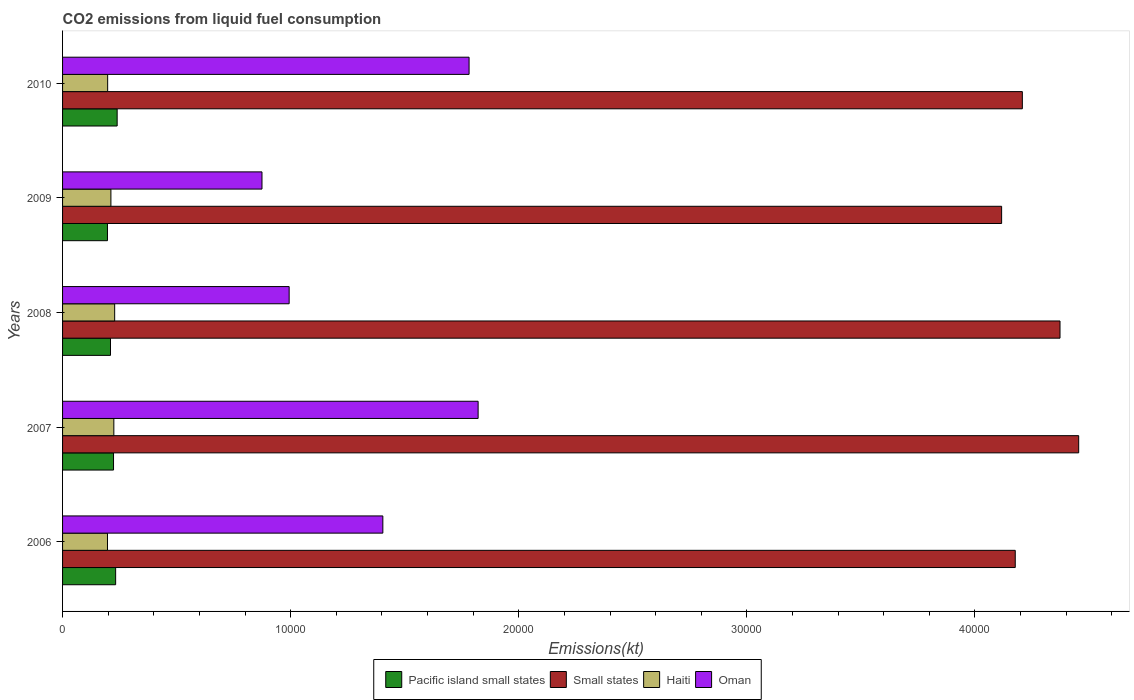How many groups of bars are there?
Your answer should be compact. 5. Are the number of bars per tick equal to the number of legend labels?
Keep it short and to the point. Yes. Are the number of bars on each tick of the Y-axis equal?
Keep it short and to the point. Yes. How many bars are there on the 5th tick from the top?
Ensure brevity in your answer.  4. What is the amount of CO2 emitted in Oman in 2006?
Ensure brevity in your answer.  1.40e+04. Across all years, what is the maximum amount of CO2 emitted in Small states?
Make the answer very short. 4.45e+04. Across all years, what is the minimum amount of CO2 emitted in Pacific island small states?
Your answer should be compact. 1968.26. In which year was the amount of CO2 emitted in Pacific island small states maximum?
Provide a succinct answer. 2010. What is the total amount of CO2 emitted in Haiti in the graph?
Keep it short and to the point. 1.06e+04. What is the difference between the amount of CO2 emitted in Haiti in 2008 and that in 2010?
Ensure brevity in your answer.  308.03. What is the difference between the amount of CO2 emitted in Pacific island small states in 2009 and the amount of CO2 emitted in Haiti in 2007?
Keep it short and to the point. -279.61. What is the average amount of CO2 emitted in Haiti per year?
Provide a short and direct response. 2119.53. In the year 2008, what is the difference between the amount of CO2 emitted in Haiti and amount of CO2 emitted in Small states?
Provide a short and direct response. -4.14e+04. In how many years, is the amount of CO2 emitted in Small states greater than 6000 kt?
Your response must be concise. 5. What is the ratio of the amount of CO2 emitted in Pacific island small states in 2008 to that in 2009?
Offer a terse response. 1.07. Is the amount of CO2 emitted in Haiti in 2006 less than that in 2008?
Provide a short and direct response. Yes. Is the difference between the amount of CO2 emitted in Haiti in 2007 and 2008 greater than the difference between the amount of CO2 emitted in Small states in 2007 and 2008?
Provide a succinct answer. No. What is the difference between the highest and the second highest amount of CO2 emitted in Pacific island small states?
Provide a succinct answer. 66.47. What is the difference between the highest and the lowest amount of CO2 emitted in Oman?
Offer a terse response. 9475.53. Is the sum of the amount of CO2 emitted in Pacific island small states in 2007 and 2010 greater than the maximum amount of CO2 emitted in Haiti across all years?
Make the answer very short. Yes. What does the 4th bar from the top in 2006 represents?
Your answer should be very brief. Pacific island small states. What does the 4th bar from the bottom in 2006 represents?
Ensure brevity in your answer.  Oman. Are all the bars in the graph horizontal?
Provide a short and direct response. Yes. How many years are there in the graph?
Your answer should be very brief. 5. What is the difference between two consecutive major ticks on the X-axis?
Provide a short and direct response. 10000. Does the graph contain any zero values?
Provide a short and direct response. No. Does the graph contain grids?
Your answer should be very brief. No. How are the legend labels stacked?
Provide a short and direct response. Horizontal. What is the title of the graph?
Provide a short and direct response. CO2 emissions from liquid fuel consumption. Does "Dominican Republic" appear as one of the legend labels in the graph?
Your response must be concise. No. What is the label or title of the X-axis?
Give a very brief answer. Emissions(kt). What is the Emissions(kt) of Pacific island small states in 2006?
Make the answer very short. 2326.46. What is the Emissions(kt) in Small states in 2006?
Give a very brief answer. 4.18e+04. What is the Emissions(kt) of Haiti in 2006?
Your answer should be compact. 1969.18. What is the Emissions(kt) of Oman in 2006?
Your answer should be compact. 1.40e+04. What is the Emissions(kt) of Pacific island small states in 2007?
Offer a very short reply. 2234.14. What is the Emissions(kt) of Small states in 2007?
Provide a short and direct response. 4.45e+04. What is the Emissions(kt) in Haiti in 2007?
Keep it short and to the point. 2247.87. What is the Emissions(kt) of Oman in 2007?
Ensure brevity in your answer.  1.82e+04. What is the Emissions(kt) of Pacific island small states in 2008?
Offer a terse response. 2101.2. What is the Emissions(kt) in Small states in 2008?
Provide a short and direct response. 4.37e+04. What is the Emissions(kt) of Haiti in 2008?
Keep it short and to the point. 2284.54. What is the Emissions(kt) of Oman in 2008?
Give a very brief answer. 9933.9. What is the Emissions(kt) in Pacific island small states in 2009?
Give a very brief answer. 1968.26. What is the Emissions(kt) of Small states in 2009?
Keep it short and to the point. 4.12e+04. What is the Emissions(kt) of Haiti in 2009?
Provide a succinct answer. 2119.53. What is the Emissions(kt) in Oman in 2009?
Offer a terse response. 8742.13. What is the Emissions(kt) in Pacific island small states in 2010?
Keep it short and to the point. 2392.93. What is the Emissions(kt) of Small states in 2010?
Provide a succinct answer. 4.21e+04. What is the Emissions(kt) of Haiti in 2010?
Provide a short and direct response. 1976.51. What is the Emissions(kt) in Oman in 2010?
Ensure brevity in your answer.  1.78e+04. Across all years, what is the maximum Emissions(kt) of Pacific island small states?
Offer a terse response. 2392.93. Across all years, what is the maximum Emissions(kt) of Small states?
Your response must be concise. 4.45e+04. Across all years, what is the maximum Emissions(kt) in Haiti?
Keep it short and to the point. 2284.54. Across all years, what is the maximum Emissions(kt) in Oman?
Make the answer very short. 1.82e+04. Across all years, what is the minimum Emissions(kt) of Pacific island small states?
Ensure brevity in your answer.  1968.26. Across all years, what is the minimum Emissions(kt) of Small states?
Give a very brief answer. 4.12e+04. Across all years, what is the minimum Emissions(kt) of Haiti?
Ensure brevity in your answer.  1969.18. Across all years, what is the minimum Emissions(kt) in Oman?
Your answer should be very brief. 8742.13. What is the total Emissions(kt) in Pacific island small states in the graph?
Your answer should be very brief. 1.10e+04. What is the total Emissions(kt) in Small states in the graph?
Your answer should be very brief. 2.13e+05. What is the total Emissions(kt) in Haiti in the graph?
Your response must be concise. 1.06e+04. What is the total Emissions(kt) in Oman in the graph?
Offer a very short reply. 6.88e+04. What is the difference between the Emissions(kt) in Pacific island small states in 2006 and that in 2007?
Give a very brief answer. 92.32. What is the difference between the Emissions(kt) of Small states in 2006 and that in 2007?
Your response must be concise. -2780.88. What is the difference between the Emissions(kt) of Haiti in 2006 and that in 2007?
Your response must be concise. -278.69. What is the difference between the Emissions(kt) in Oman in 2006 and that in 2007?
Provide a succinct answer. -4176.71. What is the difference between the Emissions(kt) in Pacific island small states in 2006 and that in 2008?
Offer a very short reply. 225.26. What is the difference between the Emissions(kt) in Small states in 2006 and that in 2008?
Offer a terse response. -1962.45. What is the difference between the Emissions(kt) of Haiti in 2006 and that in 2008?
Your answer should be very brief. -315.36. What is the difference between the Emissions(kt) in Oman in 2006 and that in 2008?
Give a very brief answer. 4107.04. What is the difference between the Emissions(kt) in Pacific island small states in 2006 and that in 2009?
Your answer should be very brief. 358.2. What is the difference between the Emissions(kt) of Small states in 2006 and that in 2009?
Offer a very short reply. 597.47. What is the difference between the Emissions(kt) of Haiti in 2006 and that in 2009?
Your answer should be compact. -150.35. What is the difference between the Emissions(kt) in Oman in 2006 and that in 2009?
Offer a very short reply. 5298.81. What is the difference between the Emissions(kt) of Pacific island small states in 2006 and that in 2010?
Your answer should be very brief. -66.47. What is the difference between the Emissions(kt) of Small states in 2006 and that in 2010?
Your answer should be compact. -310.65. What is the difference between the Emissions(kt) in Haiti in 2006 and that in 2010?
Give a very brief answer. -7.33. What is the difference between the Emissions(kt) of Oman in 2006 and that in 2010?
Provide a succinct answer. -3780.68. What is the difference between the Emissions(kt) in Pacific island small states in 2007 and that in 2008?
Your response must be concise. 132.94. What is the difference between the Emissions(kt) in Small states in 2007 and that in 2008?
Offer a terse response. 818.43. What is the difference between the Emissions(kt) of Haiti in 2007 and that in 2008?
Your answer should be very brief. -36.67. What is the difference between the Emissions(kt) of Oman in 2007 and that in 2008?
Your answer should be compact. 8283.75. What is the difference between the Emissions(kt) in Pacific island small states in 2007 and that in 2009?
Make the answer very short. 265.88. What is the difference between the Emissions(kt) of Small states in 2007 and that in 2009?
Ensure brevity in your answer.  3378.35. What is the difference between the Emissions(kt) in Haiti in 2007 and that in 2009?
Offer a terse response. 128.34. What is the difference between the Emissions(kt) of Oman in 2007 and that in 2009?
Keep it short and to the point. 9475.53. What is the difference between the Emissions(kt) of Pacific island small states in 2007 and that in 2010?
Your answer should be compact. -158.79. What is the difference between the Emissions(kt) in Small states in 2007 and that in 2010?
Make the answer very short. 2470.23. What is the difference between the Emissions(kt) of Haiti in 2007 and that in 2010?
Keep it short and to the point. 271.36. What is the difference between the Emissions(kt) of Oman in 2007 and that in 2010?
Give a very brief answer. 396.04. What is the difference between the Emissions(kt) in Pacific island small states in 2008 and that in 2009?
Give a very brief answer. 132.94. What is the difference between the Emissions(kt) in Small states in 2008 and that in 2009?
Your answer should be compact. 2559.92. What is the difference between the Emissions(kt) of Haiti in 2008 and that in 2009?
Your answer should be very brief. 165.01. What is the difference between the Emissions(kt) in Oman in 2008 and that in 2009?
Offer a terse response. 1191.78. What is the difference between the Emissions(kt) of Pacific island small states in 2008 and that in 2010?
Offer a very short reply. -291.73. What is the difference between the Emissions(kt) of Small states in 2008 and that in 2010?
Your answer should be very brief. 1651.8. What is the difference between the Emissions(kt) of Haiti in 2008 and that in 2010?
Your answer should be very brief. 308.03. What is the difference between the Emissions(kt) in Oman in 2008 and that in 2010?
Provide a succinct answer. -7887.72. What is the difference between the Emissions(kt) of Pacific island small states in 2009 and that in 2010?
Offer a very short reply. -424.67. What is the difference between the Emissions(kt) in Small states in 2009 and that in 2010?
Make the answer very short. -908.12. What is the difference between the Emissions(kt) in Haiti in 2009 and that in 2010?
Your answer should be compact. 143.01. What is the difference between the Emissions(kt) in Oman in 2009 and that in 2010?
Keep it short and to the point. -9079.49. What is the difference between the Emissions(kt) in Pacific island small states in 2006 and the Emissions(kt) in Small states in 2007?
Your response must be concise. -4.22e+04. What is the difference between the Emissions(kt) in Pacific island small states in 2006 and the Emissions(kt) in Haiti in 2007?
Your answer should be compact. 78.59. What is the difference between the Emissions(kt) in Pacific island small states in 2006 and the Emissions(kt) in Oman in 2007?
Ensure brevity in your answer.  -1.59e+04. What is the difference between the Emissions(kt) of Small states in 2006 and the Emissions(kt) of Haiti in 2007?
Give a very brief answer. 3.95e+04. What is the difference between the Emissions(kt) in Small states in 2006 and the Emissions(kt) in Oman in 2007?
Offer a very short reply. 2.35e+04. What is the difference between the Emissions(kt) of Haiti in 2006 and the Emissions(kt) of Oman in 2007?
Offer a very short reply. -1.62e+04. What is the difference between the Emissions(kt) of Pacific island small states in 2006 and the Emissions(kt) of Small states in 2008?
Give a very brief answer. -4.14e+04. What is the difference between the Emissions(kt) in Pacific island small states in 2006 and the Emissions(kt) in Haiti in 2008?
Your response must be concise. 41.92. What is the difference between the Emissions(kt) of Pacific island small states in 2006 and the Emissions(kt) of Oman in 2008?
Your answer should be very brief. -7607.44. What is the difference between the Emissions(kt) of Small states in 2006 and the Emissions(kt) of Haiti in 2008?
Your answer should be very brief. 3.95e+04. What is the difference between the Emissions(kt) of Small states in 2006 and the Emissions(kt) of Oman in 2008?
Provide a succinct answer. 3.18e+04. What is the difference between the Emissions(kt) of Haiti in 2006 and the Emissions(kt) of Oman in 2008?
Your answer should be compact. -7964.72. What is the difference between the Emissions(kt) in Pacific island small states in 2006 and the Emissions(kt) in Small states in 2009?
Your answer should be compact. -3.88e+04. What is the difference between the Emissions(kt) of Pacific island small states in 2006 and the Emissions(kt) of Haiti in 2009?
Give a very brief answer. 206.94. What is the difference between the Emissions(kt) in Pacific island small states in 2006 and the Emissions(kt) in Oman in 2009?
Your answer should be compact. -6415.66. What is the difference between the Emissions(kt) of Small states in 2006 and the Emissions(kt) of Haiti in 2009?
Ensure brevity in your answer.  3.96e+04. What is the difference between the Emissions(kt) in Small states in 2006 and the Emissions(kt) in Oman in 2009?
Offer a terse response. 3.30e+04. What is the difference between the Emissions(kt) of Haiti in 2006 and the Emissions(kt) of Oman in 2009?
Your answer should be very brief. -6772.95. What is the difference between the Emissions(kt) of Pacific island small states in 2006 and the Emissions(kt) of Small states in 2010?
Keep it short and to the point. -3.97e+04. What is the difference between the Emissions(kt) in Pacific island small states in 2006 and the Emissions(kt) in Haiti in 2010?
Offer a very short reply. 349.95. What is the difference between the Emissions(kt) of Pacific island small states in 2006 and the Emissions(kt) of Oman in 2010?
Provide a short and direct response. -1.55e+04. What is the difference between the Emissions(kt) in Small states in 2006 and the Emissions(kt) in Haiti in 2010?
Offer a very short reply. 3.98e+04. What is the difference between the Emissions(kt) in Small states in 2006 and the Emissions(kt) in Oman in 2010?
Keep it short and to the point. 2.39e+04. What is the difference between the Emissions(kt) in Haiti in 2006 and the Emissions(kt) in Oman in 2010?
Your response must be concise. -1.59e+04. What is the difference between the Emissions(kt) in Pacific island small states in 2007 and the Emissions(kt) in Small states in 2008?
Your response must be concise. -4.15e+04. What is the difference between the Emissions(kt) in Pacific island small states in 2007 and the Emissions(kt) in Haiti in 2008?
Give a very brief answer. -50.4. What is the difference between the Emissions(kt) of Pacific island small states in 2007 and the Emissions(kt) of Oman in 2008?
Your answer should be very brief. -7699.76. What is the difference between the Emissions(kt) in Small states in 2007 and the Emissions(kt) in Haiti in 2008?
Offer a very short reply. 4.23e+04. What is the difference between the Emissions(kt) of Small states in 2007 and the Emissions(kt) of Oman in 2008?
Keep it short and to the point. 3.46e+04. What is the difference between the Emissions(kt) in Haiti in 2007 and the Emissions(kt) in Oman in 2008?
Keep it short and to the point. -7686.03. What is the difference between the Emissions(kt) of Pacific island small states in 2007 and the Emissions(kt) of Small states in 2009?
Make the answer very short. -3.89e+04. What is the difference between the Emissions(kt) of Pacific island small states in 2007 and the Emissions(kt) of Haiti in 2009?
Offer a very short reply. 114.62. What is the difference between the Emissions(kt) of Pacific island small states in 2007 and the Emissions(kt) of Oman in 2009?
Your answer should be very brief. -6507.98. What is the difference between the Emissions(kt) of Small states in 2007 and the Emissions(kt) of Haiti in 2009?
Give a very brief answer. 4.24e+04. What is the difference between the Emissions(kt) of Small states in 2007 and the Emissions(kt) of Oman in 2009?
Provide a succinct answer. 3.58e+04. What is the difference between the Emissions(kt) in Haiti in 2007 and the Emissions(kt) in Oman in 2009?
Keep it short and to the point. -6494.26. What is the difference between the Emissions(kt) of Pacific island small states in 2007 and the Emissions(kt) of Small states in 2010?
Your response must be concise. -3.98e+04. What is the difference between the Emissions(kt) in Pacific island small states in 2007 and the Emissions(kt) in Haiti in 2010?
Keep it short and to the point. 257.63. What is the difference between the Emissions(kt) in Pacific island small states in 2007 and the Emissions(kt) in Oman in 2010?
Provide a succinct answer. -1.56e+04. What is the difference between the Emissions(kt) of Small states in 2007 and the Emissions(kt) of Haiti in 2010?
Provide a short and direct response. 4.26e+04. What is the difference between the Emissions(kt) in Small states in 2007 and the Emissions(kt) in Oman in 2010?
Provide a succinct answer. 2.67e+04. What is the difference between the Emissions(kt) of Haiti in 2007 and the Emissions(kt) of Oman in 2010?
Make the answer very short. -1.56e+04. What is the difference between the Emissions(kt) in Pacific island small states in 2008 and the Emissions(kt) in Small states in 2009?
Your answer should be compact. -3.91e+04. What is the difference between the Emissions(kt) in Pacific island small states in 2008 and the Emissions(kt) in Haiti in 2009?
Keep it short and to the point. -18.32. What is the difference between the Emissions(kt) in Pacific island small states in 2008 and the Emissions(kt) in Oman in 2009?
Provide a short and direct response. -6640.92. What is the difference between the Emissions(kt) in Small states in 2008 and the Emissions(kt) in Haiti in 2009?
Provide a succinct answer. 4.16e+04. What is the difference between the Emissions(kt) of Small states in 2008 and the Emissions(kt) of Oman in 2009?
Make the answer very short. 3.50e+04. What is the difference between the Emissions(kt) of Haiti in 2008 and the Emissions(kt) of Oman in 2009?
Your answer should be compact. -6457.59. What is the difference between the Emissions(kt) of Pacific island small states in 2008 and the Emissions(kt) of Small states in 2010?
Provide a short and direct response. -4.00e+04. What is the difference between the Emissions(kt) in Pacific island small states in 2008 and the Emissions(kt) in Haiti in 2010?
Offer a terse response. 124.69. What is the difference between the Emissions(kt) in Pacific island small states in 2008 and the Emissions(kt) in Oman in 2010?
Offer a terse response. -1.57e+04. What is the difference between the Emissions(kt) of Small states in 2008 and the Emissions(kt) of Haiti in 2010?
Provide a short and direct response. 4.18e+04. What is the difference between the Emissions(kt) in Small states in 2008 and the Emissions(kt) in Oman in 2010?
Provide a short and direct response. 2.59e+04. What is the difference between the Emissions(kt) in Haiti in 2008 and the Emissions(kt) in Oman in 2010?
Your response must be concise. -1.55e+04. What is the difference between the Emissions(kt) of Pacific island small states in 2009 and the Emissions(kt) of Small states in 2010?
Offer a terse response. -4.01e+04. What is the difference between the Emissions(kt) in Pacific island small states in 2009 and the Emissions(kt) in Haiti in 2010?
Give a very brief answer. -8.25. What is the difference between the Emissions(kt) in Pacific island small states in 2009 and the Emissions(kt) in Oman in 2010?
Your response must be concise. -1.59e+04. What is the difference between the Emissions(kt) of Small states in 2009 and the Emissions(kt) of Haiti in 2010?
Your response must be concise. 3.92e+04. What is the difference between the Emissions(kt) of Small states in 2009 and the Emissions(kt) of Oman in 2010?
Your response must be concise. 2.33e+04. What is the difference between the Emissions(kt) in Haiti in 2009 and the Emissions(kt) in Oman in 2010?
Provide a succinct answer. -1.57e+04. What is the average Emissions(kt) of Pacific island small states per year?
Your response must be concise. 2204.6. What is the average Emissions(kt) of Small states per year?
Your response must be concise. 4.27e+04. What is the average Emissions(kt) in Haiti per year?
Keep it short and to the point. 2119.53. What is the average Emissions(kt) of Oman per year?
Offer a terse response. 1.38e+04. In the year 2006, what is the difference between the Emissions(kt) in Pacific island small states and Emissions(kt) in Small states?
Give a very brief answer. -3.94e+04. In the year 2006, what is the difference between the Emissions(kt) in Pacific island small states and Emissions(kt) in Haiti?
Offer a very short reply. 357.29. In the year 2006, what is the difference between the Emissions(kt) of Pacific island small states and Emissions(kt) of Oman?
Your response must be concise. -1.17e+04. In the year 2006, what is the difference between the Emissions(kt) of Small states and Emissions(kt) of Haiti?
Your answer should be compact. 3.98e+04. In the year 2006, what is the difference between the Emissions(kt) of Small states and Emissions(kt) of Oman?
Offer a very short reply. 2.77e+04. In the year 2006, what is the difference between the Emissions(kt) of Haiti and Emissions(kt) of Oman?
Provide a short and direct response. -1.21e+04. In the year 2007, what is the difference between the Emissions(kt) in Pacific island small states and Emissions(kt) in Small states?
Offer a very short reply. -4.23e+04. In the year 2007, what is the difference between the Emissions(kt) of Pacific island small states and Emissions(kt) of Haiti?
Provide a succinct answer. -13.73. In the year 2007, what is the difference between the Emissions(kt) in Pacific island small states and Emissions(kt) in Oman?
Offer a terse response. -1.60e+04. In the year 2007, what is the difference between the Emissions(kt) of Small states and Emissions(kt) of Haiti?
Provide a short and direct response. 4.23e+04. In the year 2007, what is the difference between the Emissions(kt) of Small states and Emissions(kt) of Oman?
Give a very brief answer. 2.63e+04. In the year 2007, what is the difference between the Emissions(kt) of Haiti and Emissions(kt) of Oman?
Provide a succinct answer. -1.60e+04. In the year 2008, what is the difference between the Emissions(kt) of Pacific island small states and Emissions(kt) of Small states?
Provide a short and direct response. -4.16e+04. In the year 2008, what is the difference between the Emissions(kt) in Pacific island small states and Emissions(kt) in Haiti?
Provide a short and direct response. -183.34. In the year 2008, what is the difference between the Emissions(kt) in Pacific island small states and Emissions(kt) in Oman?
Provide a succinct answer. -7832.7. In the year 2008, what is the difference between the Emissions(kt) of Small states and Emissions(kt) of Haiti?
Give a very brief answer. 4.14e+04. In the year 2008, what is the difference between the Emissions(kt) of Small states and Emissions(kt) of Oman?
Offer a terse response. 3.38e+04. In the year 2008, what is the difference between the Emissions(kt) in Haiti and Emissions(kt) in Oman?
Offer a very short reply. -7649.36. In the year 2009, what is the difference between the Emissions(kt) in Pacific island small states and Emissions(kt) in Small states?
Your answer should be compact. -3.92e+04. In the year 2009, what is the difference between the Emissions(kt) of Pacific island small states and Emissions(kt) of Haiti?
Offer a very short reply. -151.26. In the year 2009, what is the difference between the Emissions(kt) in Pacific island small states and Emissions(kt) in Oman?
Make the answer very short. -6773.87. In the year 2009, what is the difference between the Emissions(kt) in Small states and Emissions(kt) in Haiti?
Offer a very short reply. 3.90e+04. In the year 2009, what is the difference between the Emissions(kt) of Small states and Emissions(kt) of Oman?
Your response must be concise. 3.24e+04. In the year 2009, what is the difference between the Emissions(kt) of Haiti and Emissions(kt) of Oman?
Your response must be concise. -6622.6. In the year 2010, what is the difference between the Emissions(kt) of Pacific island small states and Emissions(kt) of Small states?
Ensure brevity in your answer.  -3.97e+04. In the year 2010, what is the difference between the Emissions(kt) of Pacific island small states and Emissions(kt) of Haiti?
Provide a short and direct response. 416.42. In the year 2010, what is the difference between the Emissions(kt) of Pacific island small states and Emissions(kt) of Oman?
Give a very brief answer. -1.54e+04. In the year 2010, what is the difference between the Emissions(kt) in Small states and Emissions(kt) in Haiti?
Provide a succinct answer. 4.01e+04. In the year 2010, what is the difference between the Emissions(kt) of Small states and Emissions(kt) of Oman?
Your response must be concise. 2.43e+04. In the year 2010, what is the difference between the Emissions(kt) of Haiti and Emissions(kt) of Oman?
Offer a terse response. -1.58e+04. What is the ratio of the Emissions(kt) in Pacific island small states in 2006 to that in 2007?
Give a very brief answer. 1.04. What is the ratio of the Emissions(kt) of Small states in 2006 to that in 2007?
Your answer should be compact. 0.94. What is the ratio of the Emissions(kt) in Haiti in 2006 to that in 2007?
Offer a very short reply. 0.88. What is the ratio of the Emissions(kt) of Oman in 2006 to that in 2007?
Keep it short and to the point. 0.77. What is the ratio of the Emissions(kt) of Pacific island small states in 2006 to that in 2008?
Make the answer very short. 1.11. What is the ratio of the Emissions(kt) in Small states in 2006 to that in 2008?
Make the answer very short. 0.96. What is the ratio of the Emissions(kt) in Haiti in 2006 to that in 2008?
Offer a terse response. 0.86. What is the ratio of the Emissions(kt) in Oman in 2006 to that in 2008?
Your answer should be very brief. 1.41. What is the ratio of the Emissions(kt) of Pacific island small states in 2006 to that in 2009?
Provide a succinct answer. 1.18. What is the ratio of the Emissions(kt) in Small states in 2006 to that in 2009?
Your answer should be compact. 1.01. What is the ratio of the Emissions(kt) in Haiti in 2006 to that in 2009?
Your answer should be compact. 0.93. What is the ratio of the Emissions(kt) of Oman in 2006 to that in 2009?
Ensure brevity in your answer.  1.61. What is the ratio of the Emissions(kt) in Pacific island small states in 2006 to that in 2010?
Your answer should be very brief. 0.97. What is the ratio of the Emissions(kt) of Oman in 2006 to that in 2010?
Provide a short and direct response. 0.79. What is the ratio of the Emissions(kt) of Pacific island small states in 2007 to that in 2008?
Your answer should be very brief. 1.06. What is the ratio of the Emissions(kt) of Small states in 2007 to that in 2008?
Your answer should be compact. 1.02. What is the ratio of the Emissions(kt) of Haiti in 2007 to that in 2008?
Offer a very short reply. 0.98. What is the ratio of the Emissions(kt) of Oman in 2007 to that in 2008?
Keep it short and to the point. 1.83. What is the ratio of the Emissions(kt) in Pacific island small states in 2007 to that in 2009?
Offer a very short reply. 1.14. What is the ratio of the Emissions(kt) of Small states in 2007 to that in 2009?
Your answer should be very brief. 1.08. What is the ratio of the Emissions(kt) of Haiti in 2007 to that in 2009?
Offer a terse response. 1.06. What is the ratio of the Emissions(kt) of Oman in 2007 to that in 2009?
Provide a short and direct response. 2.08. What is the ratio of the Emissions(kt) of Pacific island small states in 2007 to that in 2010?
Provide a short and direct response. 0.93. What is the ratio of the Emissions(kt) in Small states in 2007 to that in 2010?
Provide a short and direct response. 1.06. What is the ratio of the Emissions(kt) in Haiti in 2007 to that in 2010?
Provide a short and direct response. 1.14. What is the ratio of the Emissions(kt) in Oman in 2007 to that in 2010?
Provide a succinct answer. 1.02. What is the ratio of the Emissions(kt) of Pacific island small states in 2008 to that in 2009?
Your answer should be compact. 1.07. What is the ratio of the Emissions(kt) of Small states in 2008 to that in 2009?
Your answer should be compact. 1.06. What is the ratio of the Emissions(kt) in Haiti in 2008 to that in 2009?
Ensure brevity in your answer.  1.08. What is the ratio of the Emissions(kt) in Oman in 2008 to that in 2009?
Your answer should be very brief. 1.14. What is the ratio of the Emissions(kt) of Pacific island small states in 2008 to that in 2010?
Keep it short and to the point. 0.88. What is the ratio of the Emissions(kt) of Small states in 2008 to that in 2010?
Your answer should be very brief. 1.04. What is the ratio of the Emissions(kt) of Haiti in 2008 to that in 2010?
Keep it short and to the point. 1.16. What is the ratio of the Emissions(kt) in Oman in 2008 to that in 2010?
Offer a terse response. 0.56. What is the ratio of the Emissions(kt) of Pacific island small states in 2009 to that in 2010?
Your answer should be very brief. 0.82. What is the ratio of the Emissions(kt) in Small states in 2009 to that in 2010?
Provide a succinct answer. 0.98. What is the ratio of the Emissions(kt) of Haiti in 2009 to that in 2010?
Keep it short and to the point. 1.07. What is the ratio of the Emissions(kt) in Oman in 2009 to that in 2010?
Give a very brief answer. 0.49. What is the difference between the highest and the second highest Emissions(kt) in Pacific island small states?
Ensure brevity in your answer.  66.47. What is the difference between the highest and the second highest Emissions(kt) of Small states?
Keep it short and to the point. 818.43. What is the difference between the highest and the second highest Emissions(kt) of Haiti?
Keep it short and to the point. 36.67. What is the difference between the highest and the second highest Emissions(kt) in Oman?
Your response must be concise. 396.04. What is the difference between the highest and the lowest Emissions(kt) of Pacific island small states?
Your response must be concise. 424.67. What is the difference between the highest and the lowest Emissions(kt) in Small states?
Give a very brief answer. 3378.35. What is the difference between the highest and the lowest Emissions(kt) of Haiti?
Provide a short and direct response. 315.36. What is the difference between the highest and the lowest Emissions(kt) in Oman?
Your answer should be compact. 9475.53. 